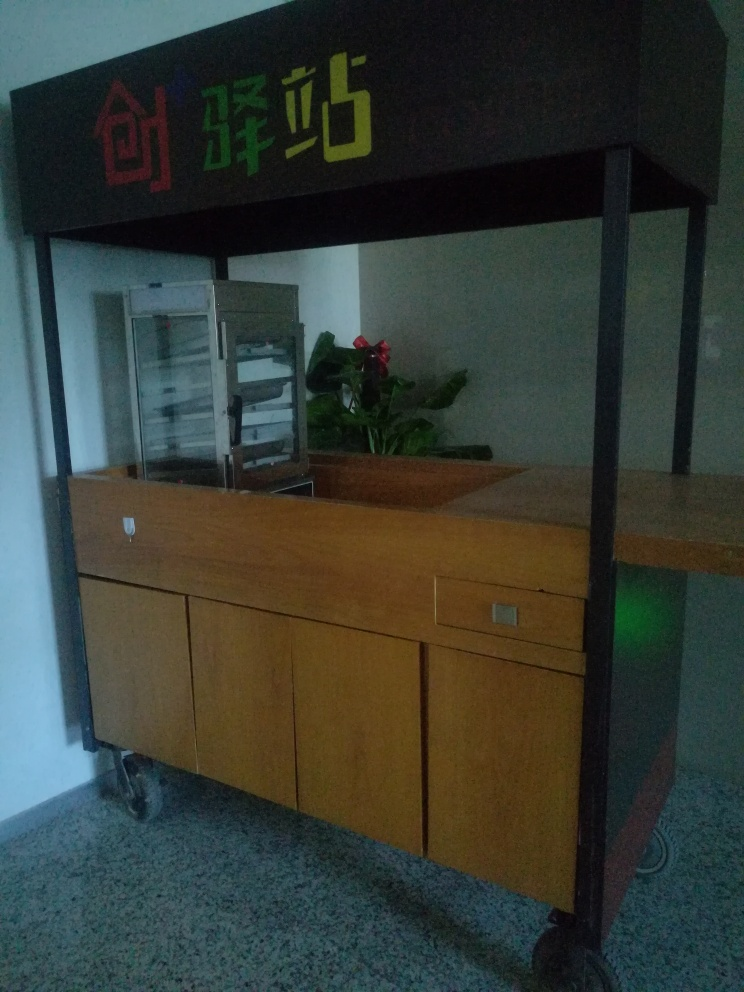What can you tell me about the overall design and condition of this piece of furniture? The furniture appears to be a mobile cabinet possibly used in an office or institutional setting, given its design and wheels at the base. The wooden finish and handle style suggest a practical design aiming for functionality. Overall, the condition looks quite maintained with no immediate signs of wear or damage. Could this be an example of sustainable furniture design? Without specific details on materials and construction processes, it's hard to conclusively determine sustainability. Yet, if the wood is sourced responsibly and the piece is designed for longevity and recyclability, it could fall under sustainable design principles. 